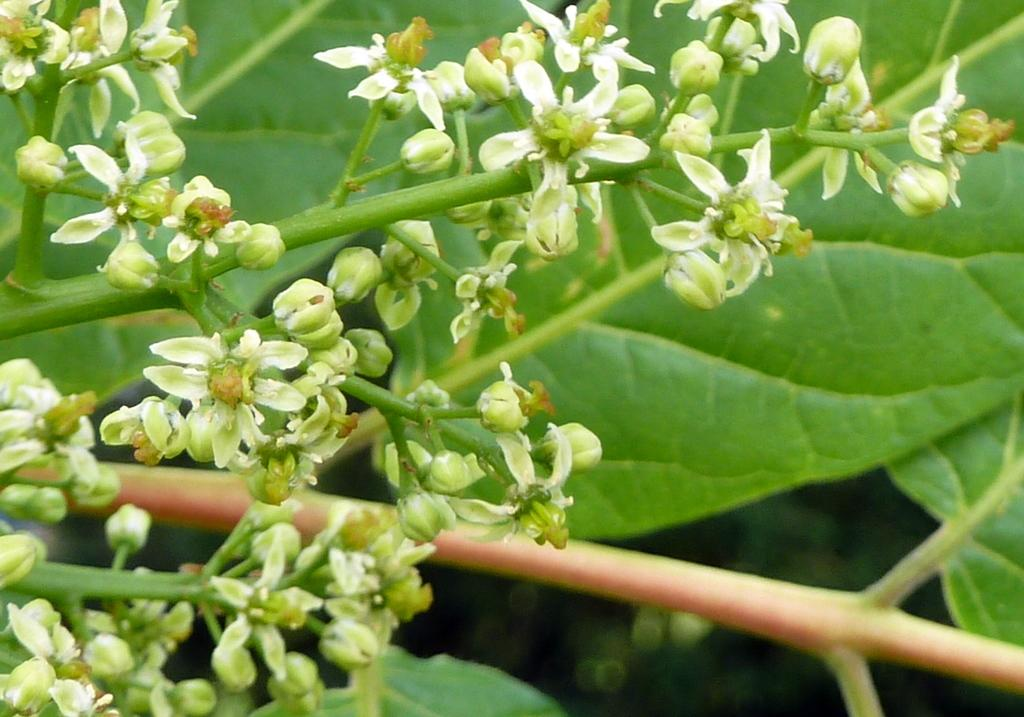What type of plant life is present in the image? There are flowers, buds, stems, and green leaves in the image. Can you describe the different parts of the plants that are visible? The image shows flowers, buds, stems, and green leaves. What color are the leaves in the image? The leaves in the image are green. What type of sugar is being used to fertilize the plants in the image? There is no sugar present in the image, and the plants are not being fertilized. 